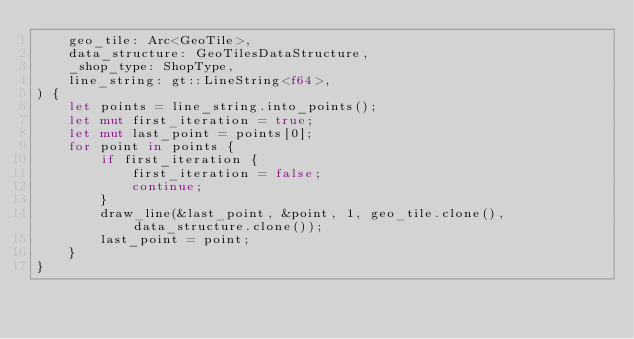<code> <loc_0><loc_0><loc_500><loc_500><_Rust_>    geo_tile: Arc<GeoTile>,
    data_structure: GeoTilesDataStructure,
    _shop_type: ShopType,
    line_string: gt::LineString<f64>,
) {
    let points = line_string.into_points();
    let mut first_iteration = true;
    let mut last_point = points[0];
    for point in points {
        if first_iteration {
            first_iteration = false;
            continue;
        }
        draw_line(&last_point, &point, 1, geo_tile.clone(), data_structure.clone());
        last_point = point;
    }
}
</code> 